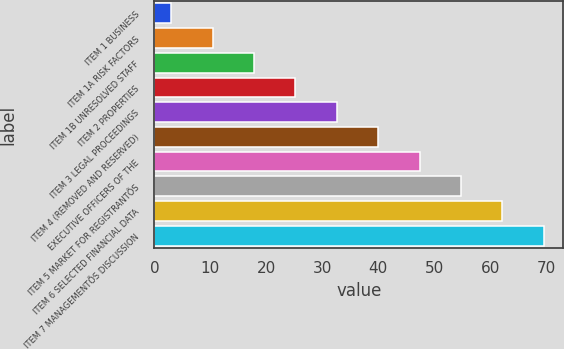Convert chart. <chart><loc_0><loc_0><loc_500><loc_500><bar_chart><fcel>ITEM 1 BUSINESS<fcel>ITEM 1A RISK FACTORS<fcel>ITEM 1B UNRESOLVED STAFF<fcel>ITEM 2 PROPERTIES<fcel>ITEM 3 LEGAL PROCEEDINGS<fcel>ITEM 4 (REMOVED AND RESERVED)<fcel>EXECUTIVE OFFICERS OF THE<fcel>ITEM 5 MARKET FOR REGISTRANTÕS<fcel>ITEM 6 SELECTED FINANCIAL DATA<fcel>ITEM 7 MANAGEMENTÕS DISCUSSION<nl><fcel>3<fcel>10.4<fcel>17.8<fcel>25.2<fcel>32.6<fcel>40<fcel>47.4<fcel>54.8<fcel>62.2<fcel>69.6<nl></chart> 